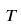<formula> <loc_0><loc_0><loc_500><loc_500>T</formula> 